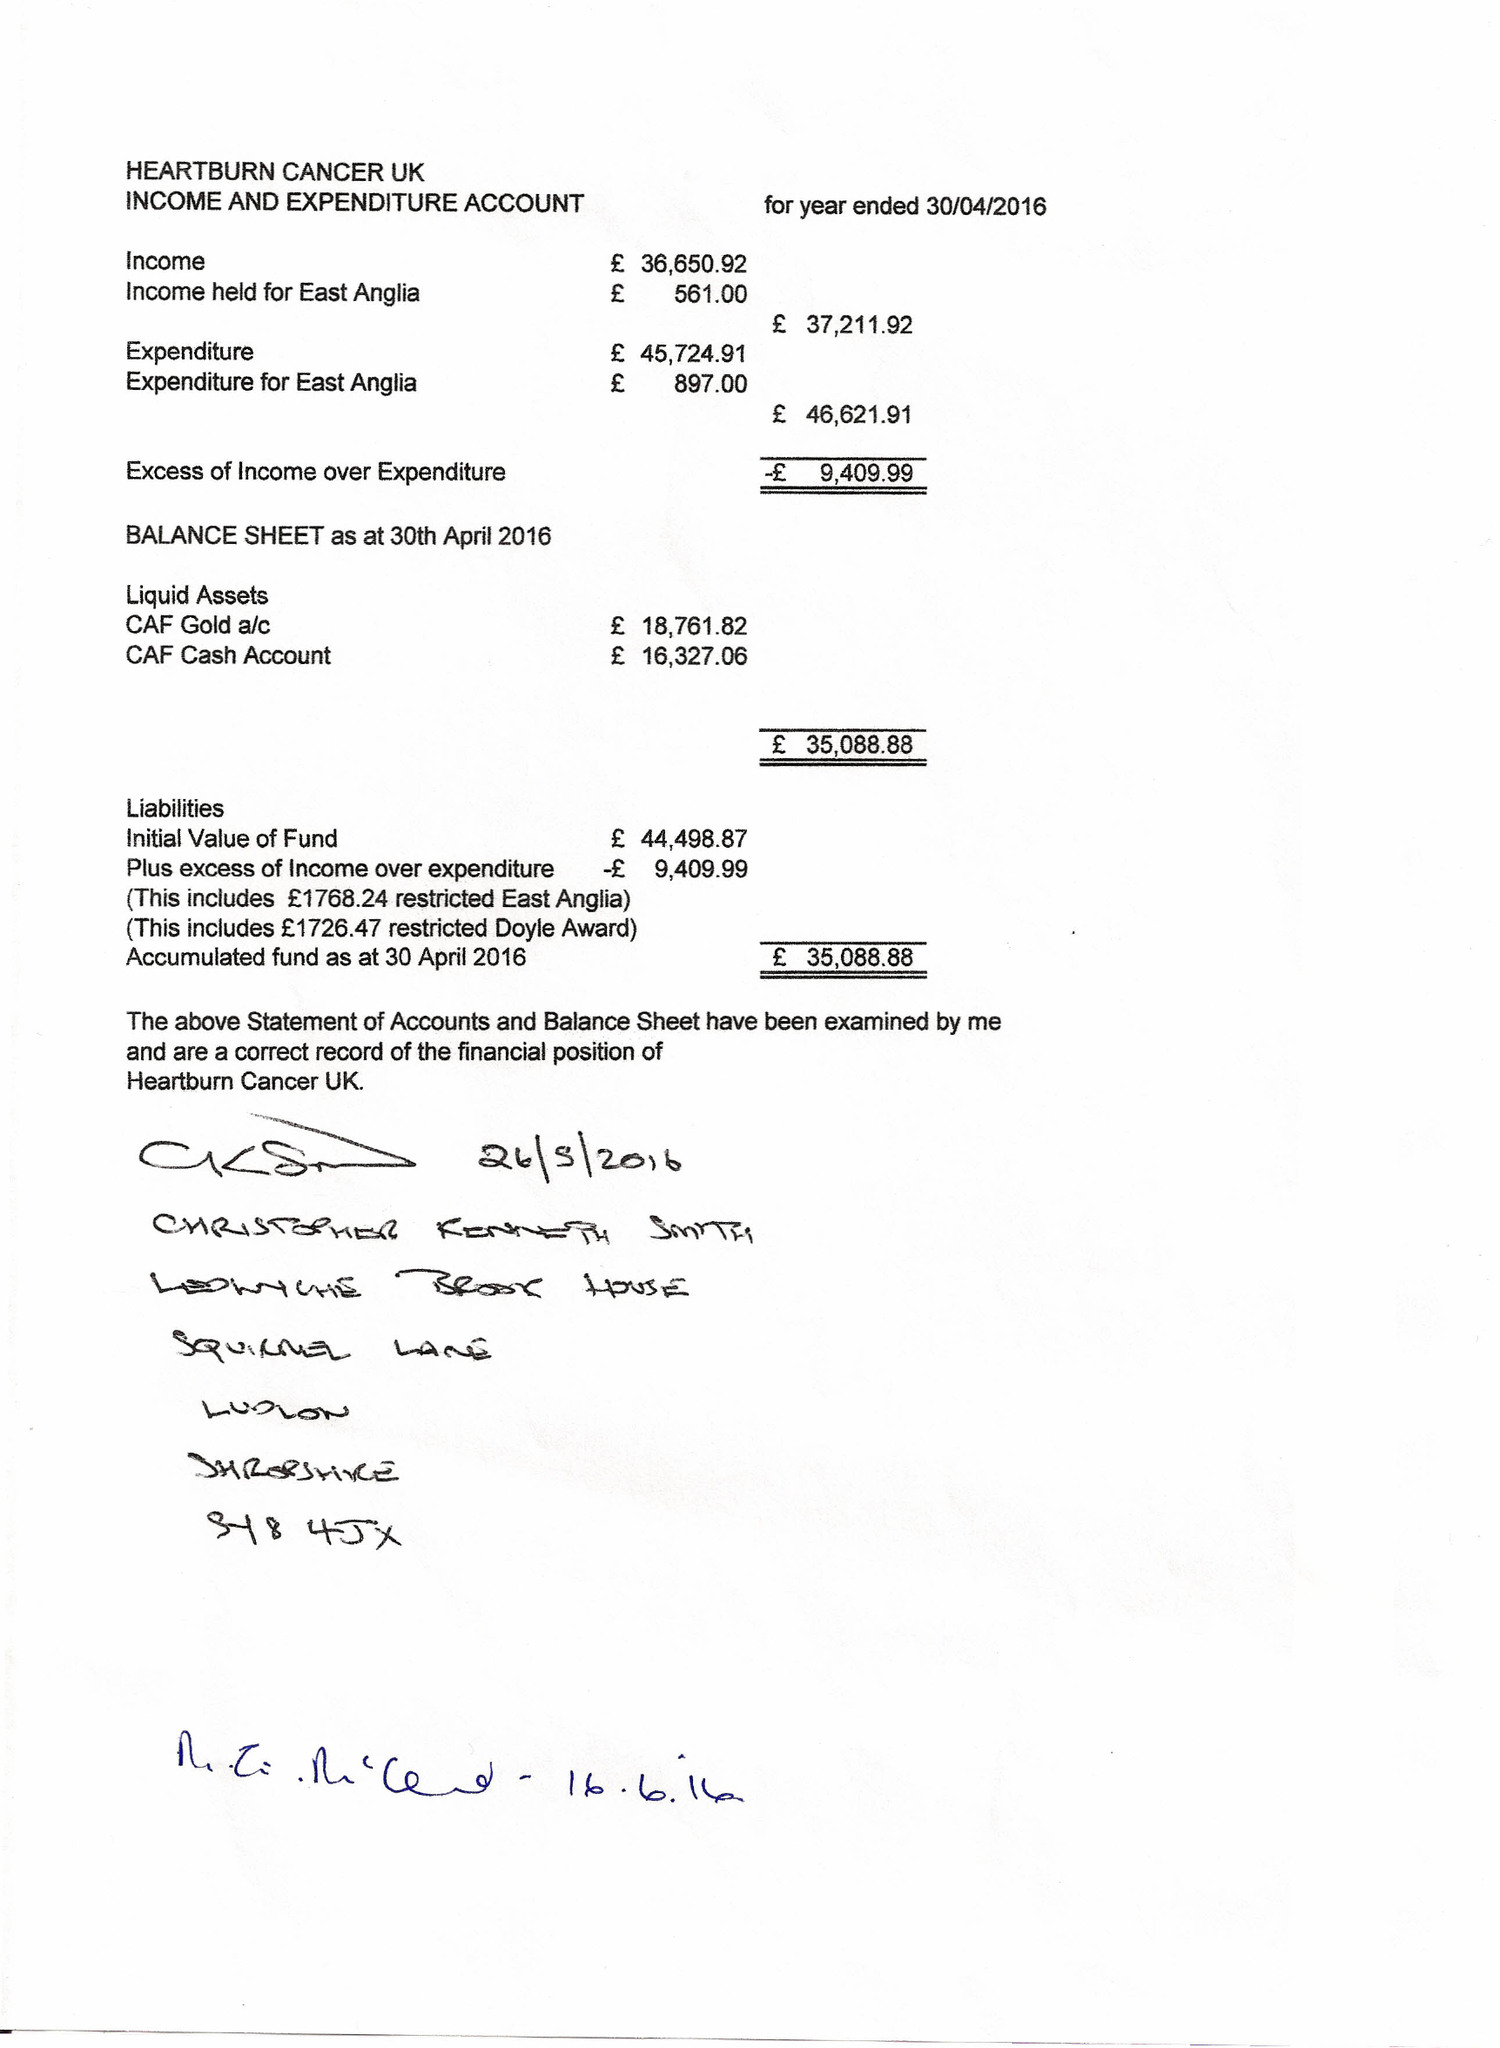What is the value for the address__postcode?
Answer the question using a single word or phrase. PO18 8QB 